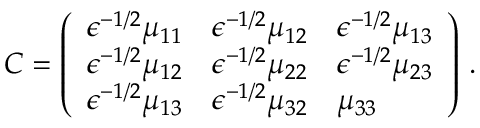Convert formula to latex. <formula><loc_0><loc_0><loc_500><loc_500>C = \left ( \begin{array} { l l l } { \epsilon ^ { - 1 / 2 } \mu _ { 1 1 } } & { \epsilon ^ { - 1 / 2 } \mu _ { 1 2 } } & { \epsilon ^ { - 1 / 2 } \mu _ { 1 3 } } \\ { \epsilon ^ { - 1 / 2 } \mu _ { 1 2 } } & { \epsilon ^ { - 1 / 2 } \mu _ { 2 2 } } & { \epsilon ^ { - 1 / 2 } \mu _ { 2 3 } } \\ { \epsilon ^ { - 1 / 2 } \mu _ { 1 3 } } & { \epsilon ^ { - 1 / 2 } \mu _ { 3 2 } } & { \mu _ { 3 3 } } \end{array} \right ) \, .</formula> 